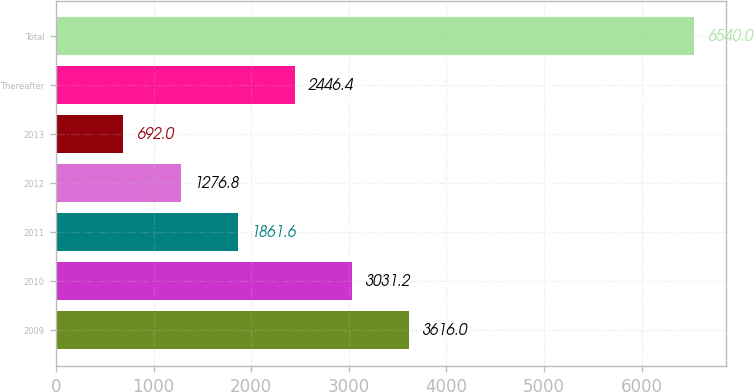<chart> <loc_0><loc_0><loc_500><loc_500><bar_chart><fcel>2009<fcel>2010<fcel>2011<fcel>2012<fcel>2013<fcel>Thereafter<fcel>Total<nl><fcel>3616<fcel>3031.2<fcel>1861.6<fcel>1276.8<fcel>692<fcel>2446.4<fcel>6540<nl></chart> 